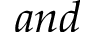<formula> <loc_0><loc_0><loc_500><loc_500>a n d</formula> 